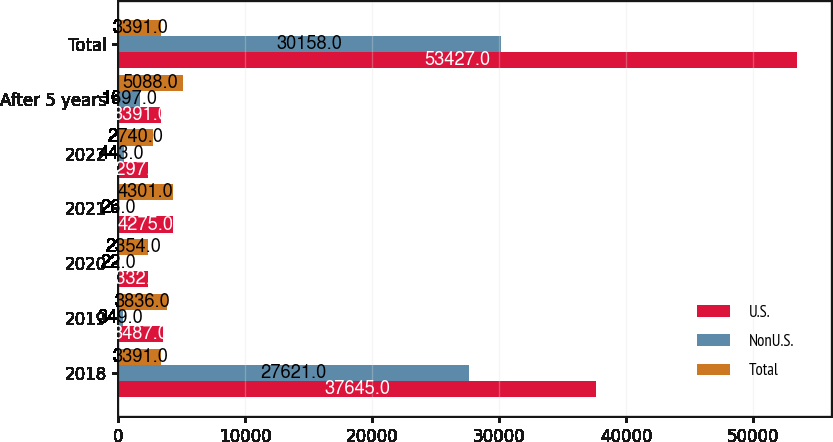Convert chart to OTSL. <chart><loc_0><loc_0><loc_500><loc_500><stacked_bar_chart><ecel><fcel>2018<fcel>2019<fcel>2020<fcel>2021<fcel>2022<fcel>After 5 years<fcel>Total<nl><fcel>U.S.<fcel>37645<fcel>3487<fcel>2332<fcel>4275<fcel>2297<fcel>3391<fcel>53427<nl><fcel>NonU.S.<fcel>27621<fcel>349<fcel>22<fcel>26<fcel>443<fcel>1697<fcel>30158<nl><fcel>Total<fcel>3391<fcel>3836<fcel>2354<fcel>4301<fcel>2740<fcel>5088<fcel>3391<nl></chart> 